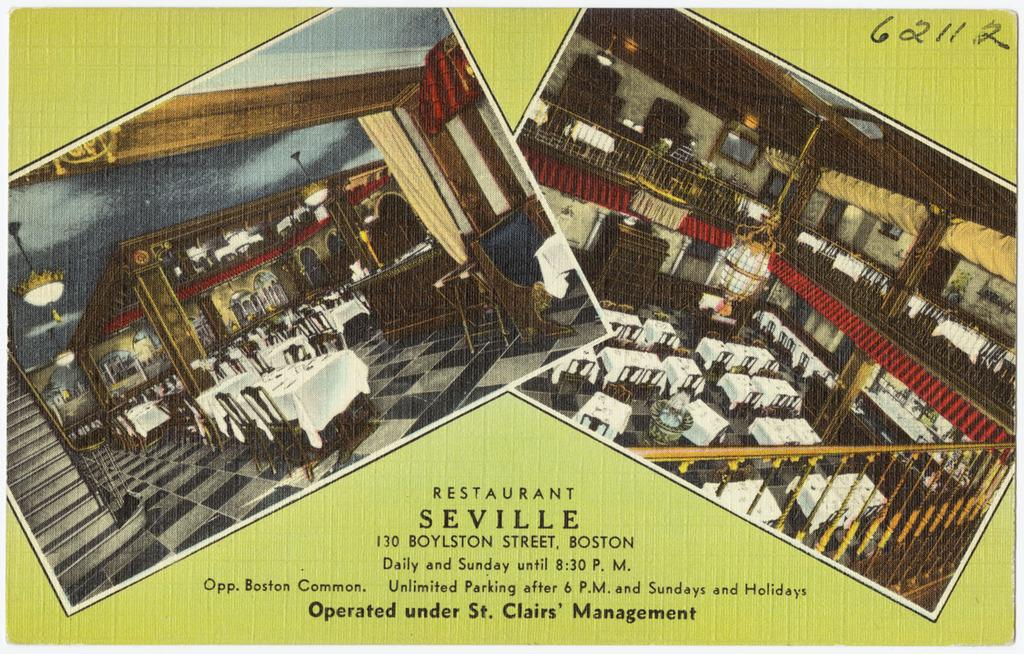<image>
Relay a brief, clear account of the picture shown. Ad for Restaurant Seville that is located in Boston. 